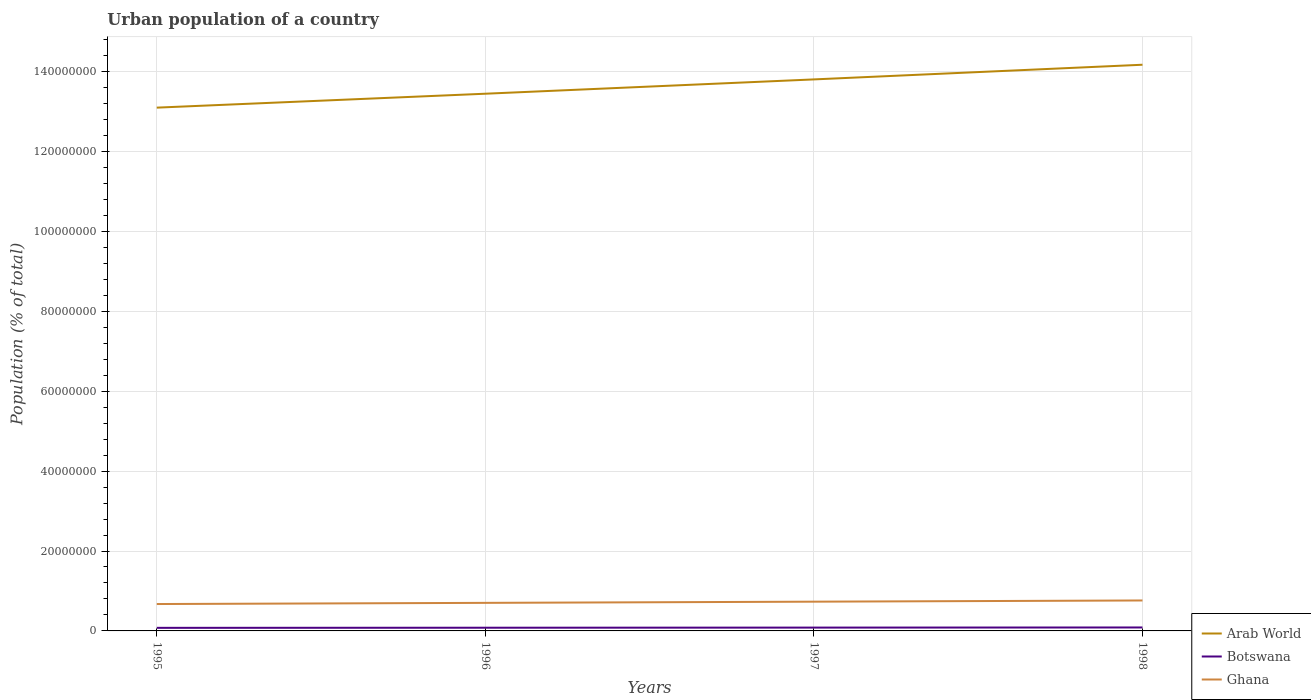How many different coloured lines are there?
Offer a terse response. 3. Does the line corresponding to Botswana intersect with the line corresponding to Arab World?
Keep it short and to the point. No. Is the number of lines equal to the number of legend labels?
Your response must be concise. Yes. Across all years, what is the maximum urban population in Ghana?
Offer a terse response. 6.73e+06. What is the total urban population in Arab World in the graph?
Make the answer very short. -3.49e+06. What is the difference between the highest and the second highest urban population in Ghana?
Provide a succinct answer. 8.94e+05. Is the urban population in Botswana strictly greater than the urban population in Arab World over the years?
Make the answer very short. Yes. How many lines are there?
Your response must be concise. 3. How many years are there in the graph?
Give a very brief answer. 4. Are the values on the major ticks of Y-axis written in scientific E-notation?
Make the answer very short. No. Does the graph contain any zero values?
Provide a short and direct response. No. Does the graph contain grids?
Offer a very short reply. Yes. What is the title of the graph?
Your answer should be compact. Urban population of a country. Does "Isle of Man" appear as one of the legend labels in the graph?
Your answer should be very brief. No. What is the label or title of the Y-axis?
Keep it short and to the point. Population (% of total). What is the Population (% of total) of Arab World in 1995?
Offer a terse response. 1.31e+08. What is the Population (% of total) of Botswana in 1995?
Provide a succinct answer. 7.72e+05. What is the Population (% of total) of Ghana in 1995?
Offer a very short reply. 6.73e+06. What is the Population (% of total) in Arab World in 1996?
Offer a very short reply. 1.34e+08. What is the Population (% of total) in Botswana in 1996?
Provide a succinct answer. 8.03e+05. What is the Population (% of total) in Ghana in 1996?
Make the answer very short. 7.02e+06. What is the Population (% of total) of Arab World in 1997?
Your answer should be compact. 1.38e+08. What is the Population (% of total) in Botswana in 1997?
Give a very brief answer. 8.34e+05. What is the Population (% of total) in Ghana in 1997?
Ensure brevity in your answer.  7.32e+06. What is the Population (% of total) in Arab World in 1998?
Give a very brief answer. 1.42e+08. What is the Population (% of total) of Botswana in 1998?
Your answer should be compact. 8.65e+05. What is the Population (% of total) of Ghana in 1998?
Your answer should be compact. 7.62e+06. Across all years, what is the maximum Population (% of total) of Arab World?
Your answer should be compact. 1.42e+08. Across all years, what is the maximum Population (% of total) of Botswana?
Your response must be concise. 8.65e+05. Across all years, what is the maximum Population (% of total) in Ghana?
Make the answer very short. 7.62e+06. Across all years, what is the minimum Population (% of total) of Arab World?
Make the answer very short. 1.31e+08. Across all years, what is the minimum Population (% of total) of Botswana?
Your answer should be very brief. 7.72e+05. Across all years, what is the minimum Population (% of total) of Ghana?
Offer a very short reply. 6.73e+06. What is the total Population (% of total) in Arab World in the graph?
Make the answer very short. 5.45e+08. What is the total Population (% of total) of Botswana in the graph?
Provide a short and direct response. 3.27e+06. What is the total Population (% of total) of Ghana in the graph?
Provide a short and direct response. 2.87e+07. What is the difference between the Population (% of total) in Arab World in 1995 and that in 1996?
Make the answer very short. -3.49e+06. What is the difference between the Population (% of total) in Botswana in 1995 and that in 1996?
Ensure brevity in your answer.  -3.11e+04. What is the difference between the Population (% of total) in Ghana in 1995 and that in 1996?
Your answer should be compact. -2.94e+05. What is the difference between the Population (% of total) in Arab World in 1995 and that in 1997?
Make the answer very short. -7.07e+06. What is the difference between the Population (% of total) of Botswana in 1995 and that in 1997?
Give a very brief answer. -6.20e+04. What is the difference between the Population (% of total) of Ghana in 1995 and that in 1997?
Your response must be concise. -5.90e+05. What is the difference between the Population (% of total) of Arab World in 1995 and that in 1998?
Offer a very short reply. -1.07e+07. What is the difference between the Population (% of total) of Botswana in 1995 and that in 1998?
Your answer should be compact. -9.26e+04. What is the difference between the Population (% of total) in Ghana in 1995 and that in 1998?
Give a very brief answer. -8.94e+05. What is the difference between the Population (% of total) of Arab World in 1996 and that in 1997?
Keep it short and to the point. -3.58e+06. What is the difference between the Population (% of total) of Botswana in 1996 and that in 1997?
Provide a succinct answer. -3.09e+04. What is the difference between the Population (% of total) of Ghana in 1996 and that in 1997?
Offer a very short reply. -2.96e+05. What is the difference between the Population (% of total) in Arab World in 1996 and that in 1998?
Provide a succinct answer. -7.25e+06. What is the difference between the Population (% of total) of Botswana in 1996 and that in 1998?
Keep it short and to the point. -6.15e+04. What is the difference between the Population (% of total) of Ghana in 1996 and that in 1998?
Give a very brief answer. -6.01e+05. What is the difference between the Population (% of total) of Arab World in 1997 and that in 1998?
Your answer should be compact. -3.67e+06. What is the difference between the Population (% of total) in Botswana in 1997 and that in 1998?
Provide a short and direct response. -3.06e+04. What is the difference between the Population (% of total) of Ghana in 1997 and that in 1998?
Your answer should be compact. -3.04e+05. What is the difference between the Population (% of total) of Arab World in 1995 and the Population (% of total) of Botswana in 1996?
Keep it short and to the point. 1.30e+08. What is the difference between the Population (% of total) of Arab World in 1995 and the Population (% of total) of Ghana in 1996?
Provide a short and direct response. 1.24e+08. What is the difference between the Population (% of total) of Botswana in 1995 and the Population (% of total) of Ghana in 1996?
Your answer should be very brief. -6.25e+06. What is the difference between the Population (% of total) of Arab World in 1995 and the Population (% of total) of Botswana in 1997?
Provide a short and direct response. 1.30e+08. What is the difference between the Population (% of total) of Arab World in 1995 and the Population (% of total) of Ghana in 1997?
Ensure brevity in your answer.  1.24e+08. What is the difference between the Population (% of total) of Botswana in 1995 and the Population (% of total) of Ghana in 1997?
Your response must be concise. -6.55e+06. What is the difference between the Population (% of total) in Arab World in 1995 and the Population (% of total) in Botswana in 1998?
Ensure brevity in your answer.  1.30e+08. What is the difference between the Population (% of total) in Arab World in 1995 and the Population (% of total) in Ghana in 1998?
Offer a very short reply. 1.23e+08. What is the difference between the Population (% of total) of Botswana in 1995 and the Population (% of total) of Ghana in 1998?
Give a very brief answer. -6.85e+06. What is the difference between the Population (% of total) of Arab World in 1996 and the Population (% of total) of Botswana in 1997?
Your answer should be compact. 1.34e+08. What is the difference between the Population (% of total) in Arab World in 1996 and the Population (% of total) in Ghana in 1997?
Ensure brevity in your answer.  1.27e+08. What is the difference between the Population (% of total) in Botswana in 1996 and the Population (% of total) in Ghana in 1997?
Ensure brevity in your answer.  -6.51e+06. What is the difference between the Population (% of total) of Arab World in 1996 and the Population (% of total) of Botswana in 1998?
Your answer should be compact. 1.34e+08. What is the difference between the Population (% of total) of Arab World in 1996 and the Population (% of total) of Ghana in 1998?
Provide a succinct answer. 1.27e+08. What is the difference between the Population (% of total) in Botswana in 1996 and the Population (% of total) in Ghana in 1998?
Your response must be concise. -6.82e+06. What is the difference between the Population (% of total) in Arab World in 1997 and the Population (% of total) in Botswana in 1998?
Ensure brevity in your answer.  1.37e+08. What is the difference between the Population (% of total) in Arab World in 1997 and the Population (% of total) in Ghana in 1998?
Make the answer very short. 1.30e+08. What is the difference between the Population (% of total) of Botswana in 1997 and the Population (% of total) of Ghana in 1998?
Keep it short and to the point. -6.79e+06. What is the average Population (% of total) of Arab World per year?
Provide a succinct answer. 1.36e+08. What is the average Population (% of total) in Botswana per year?
Your answer should be compact. 8.18e+05. What is the average Population (% of total) of Ghana per year?
Offer a terse response. 7.17e+06. In the year 1995, what is the difference between the Population (% of total) in Arab World and Population (% of total) in Botswana?
Your answer should be very brief. 1.30e+08. In the year 1995, what is the difference between the Population (% of total) in Arab World and Population (% of total) in Ghana?
Ensure brevity in your answer.  1.24e+08. In the year 1995, what is the difference between the Population (% of total) in Botswana and Population (% of total) in Ghana?
Ensure brevity in your answer.  -5.96e+06. In the year 1996, what is the difference between the Population (% of total) of Arab World and Population (% of total) of Botswana?
Provide a succinct answer. 1.34e+08. In the year 1996, what is the difference between the Population (% of total) in Arab World and Population (% of total) in Ghana?
Provide a succinct answer. 1.27e+08. In the year 1996, what is the difference between the Population (% of total) of Botswana and Population (% of total) of Ghana?
Offer a terse response. -6.22e+06. In the year 1997, what is the difference between the Population (% of total) of Arab World and Population (% of total) of Botswana?
Keep it short and to the point. 1.37e+08. In the year 1997, what is the difference between the Population (% of total) in Arab World and Population (% of total) in Ghana?
Make the answer very short. 1.31e+08. In the year 1997, what is the difference between the Population (% of total) of Botswana and Population (% of total) of Ghana?
Your response must be concise. -6.48e+06. In the year 1998, what is the difference between the Population (% of total) in Arab World and Population (% of total) in Botswana?
Provide a short and direct response. 1.41e+08. In the year 1998, what is the difference between the Population (% of total) in Arab World and Population (% of total) in Ghana?
Offer a very short reply. 1.34e+08. In the year 1998, what is the difference between the Population (% of total) of Botswana and Population (% of total) of Ghana?
Offer a very short reply. -6.76e+06. What is the ratio of the Population (% of total) of Arab World in 1995 to that in 1996?
Ensure brevity in your answer.  0.97. What is the ratio of the Population (% of total) in Botswana in 1995 to that in 1996?
Provide a short and direct response. 0.96. What is the ratio of the Population (% of total) of Ghana in 1995 to that in 1996?
Offer a very short reply. 0.96. What is the ratio of the Population (% of total) in Arab World in 1995 to that in 1997?
Offer a terse response. 0.95. What is the ratio of the Population (% of total) of Botswana in 1995 to that in 1997?
Your response must be concise. 0.93. What is the ratio of the Population (% of total) of Ghana in 1995 to that in 1997?
Keep it short and to the point. 0.92. What is the ratio of the Population (% of total) in Arab World in 1995 to that in 1998?
Your response must be concise. 0.92. What is the ratio of the Population (% of total) in Botswana in 1995 to that in 1998?
Your answer should be compact. 0.89. What is the ratio of the Population (% of total) of Ghana in 1995 to that in 1998?
Your answer should be compact. 0.88. What is the ratio of the Population (% of total) of Arab World in 1996 to that in 1997?
Offer a terse response. 0.97. What is the ratio of the Population (% of total) in Botswana in 1996 to that in 1997?
Offer a terse response. 0.96. What is the ratio of the Population (% of total) of Ghana in 1996 to that in 1997?
Your answer should be compact. 0.96. What is the ratio of the Population (% of total) of Arab World in 1996 to that in 1998?
Make the answer very short. 0.95. What is the ratio of the Population (% of total) of Botswana in 1996 to that in 1998?
Give a very brief answer. 0.93. What is the ratio of the Population (% of total) of Ghana in 1996 to that in 1998?
Offer a very short reply. 0.92. What is the ratio of the Population (% of total) of Arab World in 1997 to that in 1998?
Make the answer very short. 0.97. What is the ratio of the Population (% of total) of Botswana in 1997 to that in 1998?
Provide a short and direct response. 0.96. What is the ratio of the Population (% of total) in Ghana in 1997 to that in 1998?
Offer a very short reply. 0.96. What is the difference between the highest and the second highest Population (% of total) in Arab World?
Provide a short and direct response. 3.67e+06. What is the difference between the highest and the second highest Population (% of total) in Botswana?
Your response must be concise. 3.06e+04. What is the difference between the highest and the second highest Population (% of total) in Ghana?
Keep it short and to the point. 3.04e+05. What is the difference between the highest and the lowest Population (% of total) of Arab World?
Provide a succinct answer. 1.07e+07. What is the difference between the highest and the lowest Population (% of total) of Botswana?
Your response must be concise. 9.26e+04. What is the difference between the highest and the lowest Population (% of total) in Ghana?
Ensure brevity in your answer.  8.94e+05. 